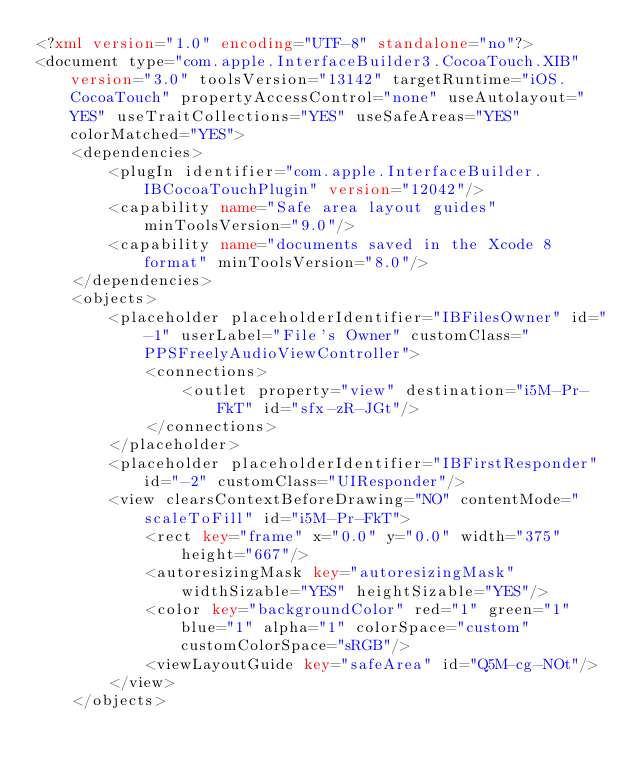Convert code to text. <code><loc_0><loc_0><loc_500><loc_500><_XML_><?xml version="1.0" encoding="UTF-8" standalone="no"?>
<document type="com.apple.InterfaceBuilder3.CocoaTouch.XIB" version="3.0" toolsVersion="13142" targetRuntime="iOS.CocoaTouch" propertyAccessControl="none" useAutolayout="YES" useTraitCollections="YES" useSafeAreas="YES" colorMatched="YES">
    <dependencies>
        <plugIn identifier="com.apple.InterfaceBuilder.IBCocoaTouchPlugin" version="12042"/>
        <capability name="Safe area layout guides" minToolsVersion="9.0"/>
        <capability name="documents saved in the Xcode 8 format" minToolsVersion="8.0"/>
    </dependencies>
    <objects>
        <placeholder placeholderIdentifier="IBFilesOwner" id="-1" userLabel="File's Owner" customClass="PPSFreelyAudioViewController">
            <connections>
                <outlet property="view" destination="i5M-Pr-FkT" id="sfx-zR-JGt"/>
            </connections>
        </placeholder>
        <placeholder placeholderIdentifier="IBFirstResponder" id="-2" customClass="UIResponder"/>
        <view clearsContextBeforeDrawing="NO" contentMode="scaleToFill" id="i5M-Pr-FkT">
            <rect key="frame" x="0.0" y="0.0" width="375" height="667"/>
            <autoresizingMask key="autoresizingMask" widthSizable="YES" heightSizable="YES"/>
            <color key="backgroundColor" red="1" green="1" blue="1" alpha="1" colorSpace="custom" customColorSpace="sRGB"/>
            <viewLayoutGuide key="safeArea" id="Q5M-cg-NOt"/>
        </view>
    </objects></code> 